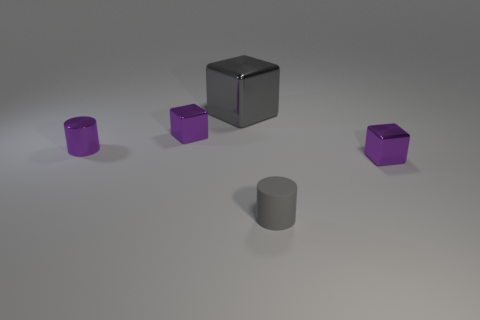The other object that is the same color as the large object is what size?
Offer a very short reply. Small. There is a gray matte object; are there any gray rubber cylinders in front of it?
Your response must be concise. No. The tiny block left of the tiny gray rubber cylinder is what color?
Make the answer very short. Purple. There is a tiny cube behind the small cylinder behind the tiny gray cylinder; what is it made of?
Offer a very short reply. Metal. Are there fewer cylinders that are to the right of the gray rubber cylinder than tiny purple cubes to the right of the big shiny thing?
Make the answer very short. Yes. How many green objects are matte objects or small metal things?
Give a very brief answer. 0. Are there an equal number of tiny purple metallic cubes to the left of the big gray thing and large yellow matte balls?
Your response must be concise. No. What number of objects are gray metal things or gray things that are in front of the big metal thing?
Your answer should be compact. 2. Does the tiny rubber object have the same color as the metallic cylinder?
Ensure brevity in your answer.  No. Is there another cylinder made of the same material as the small gray cylinder?
Ensure brevity in your answer.  No. 